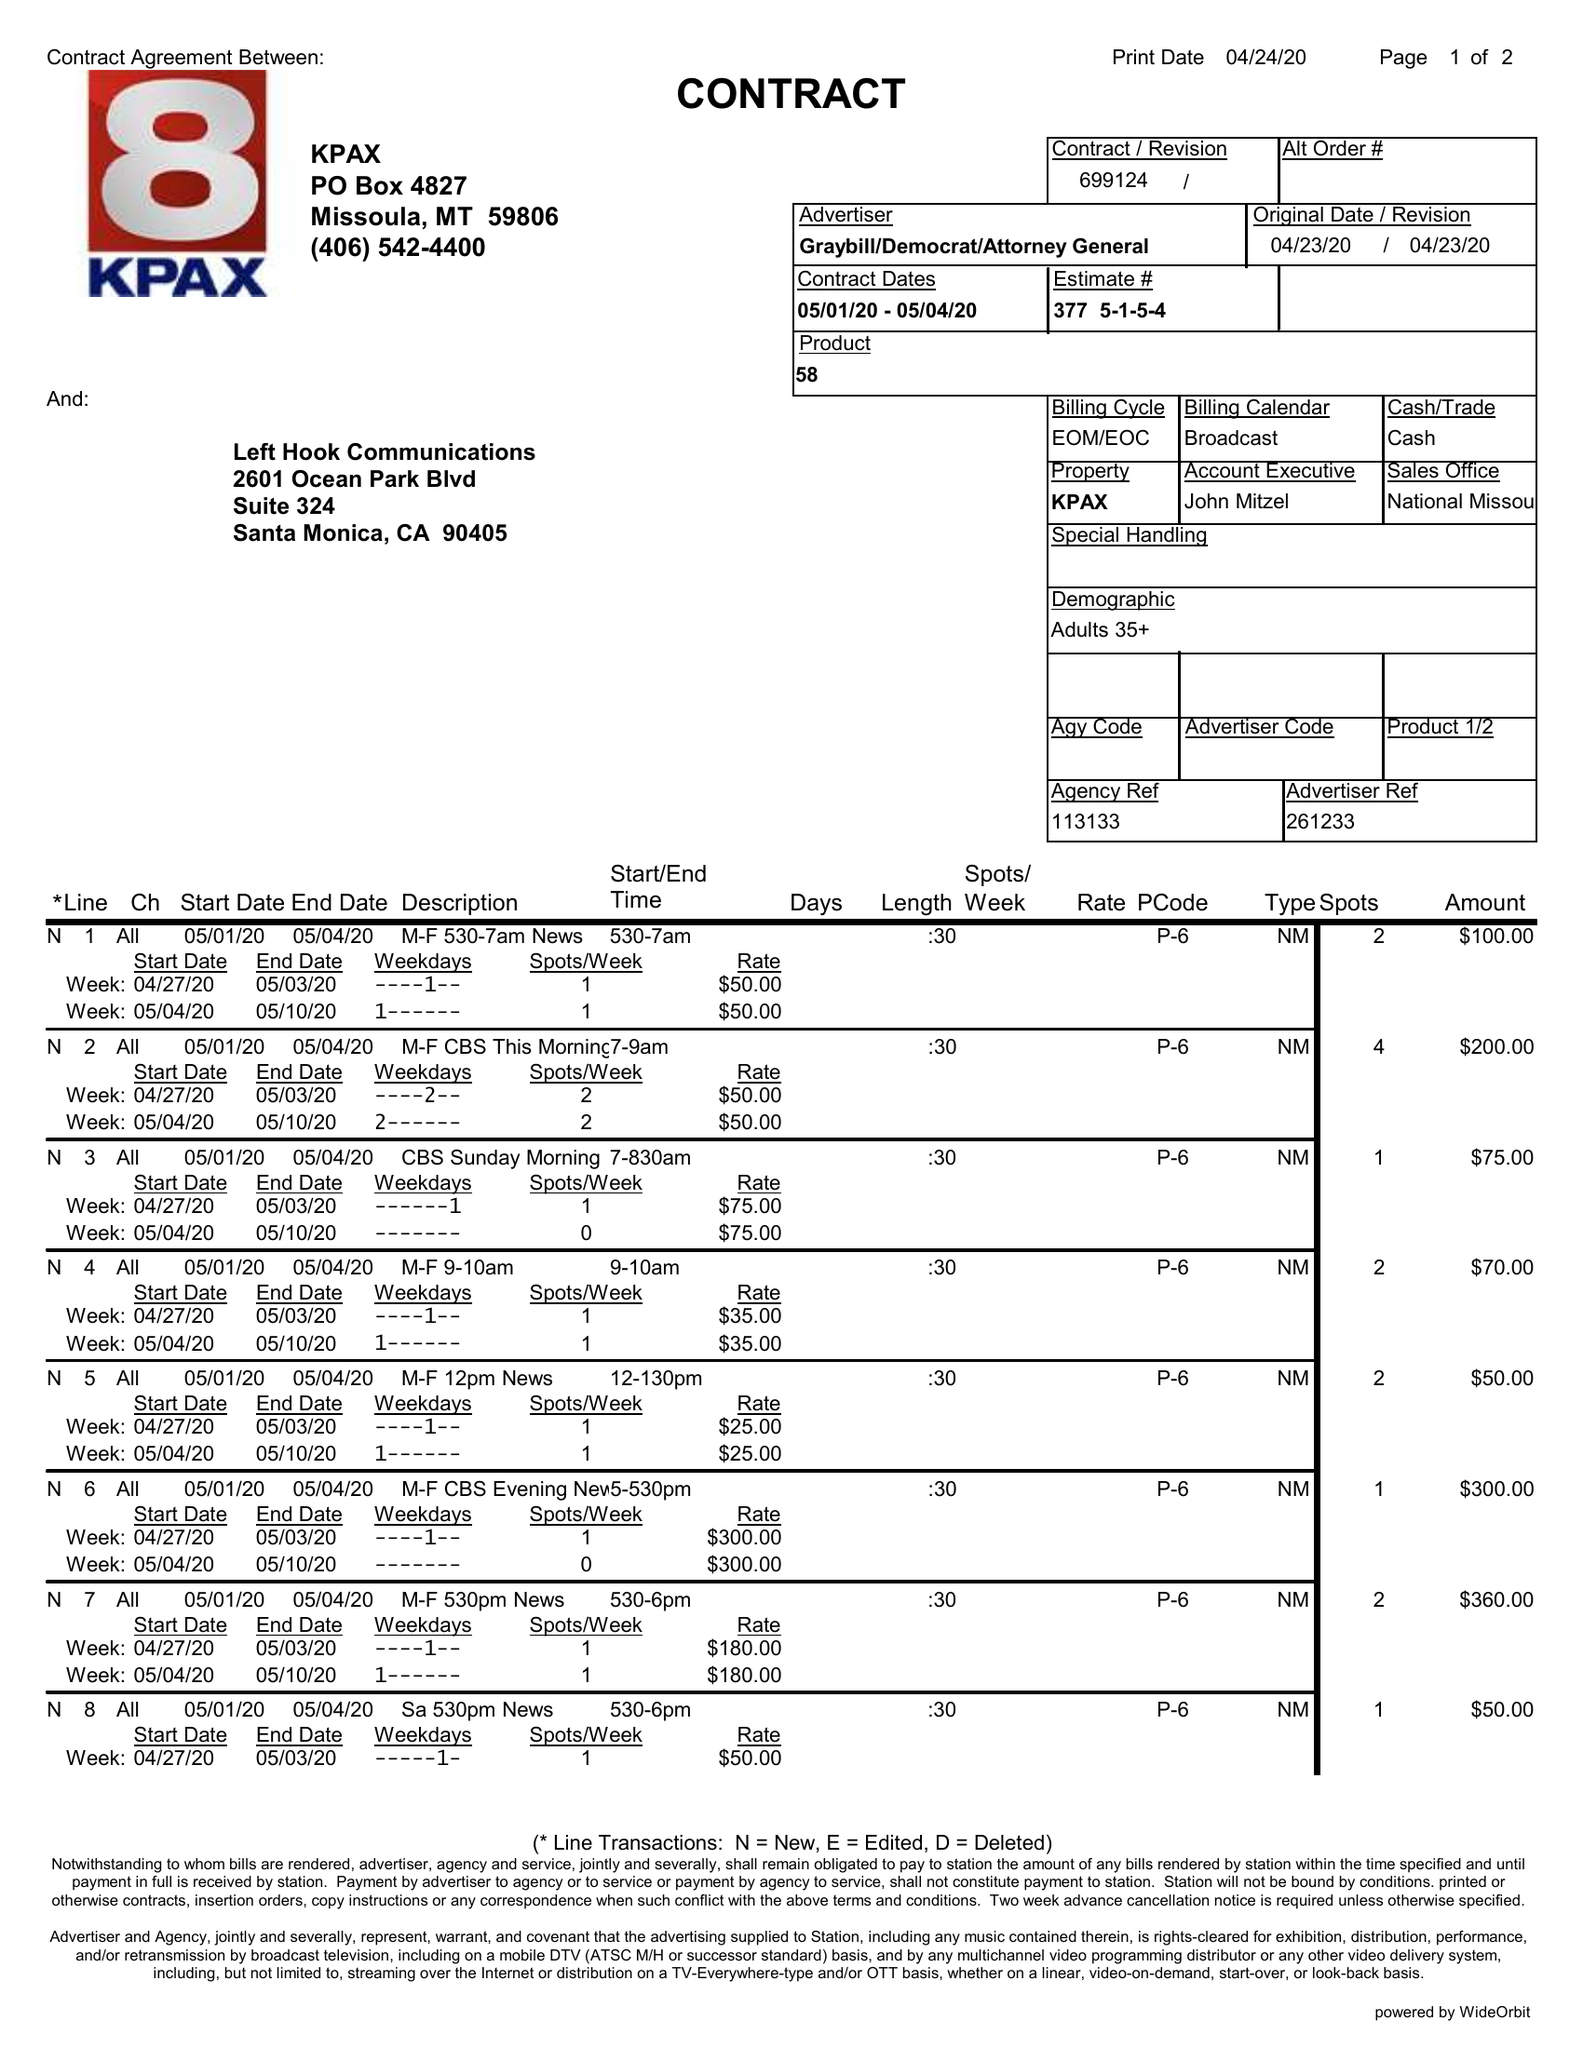What is the value for the flight_to?
Answer the question using a single word or phrase. 05/04/20 